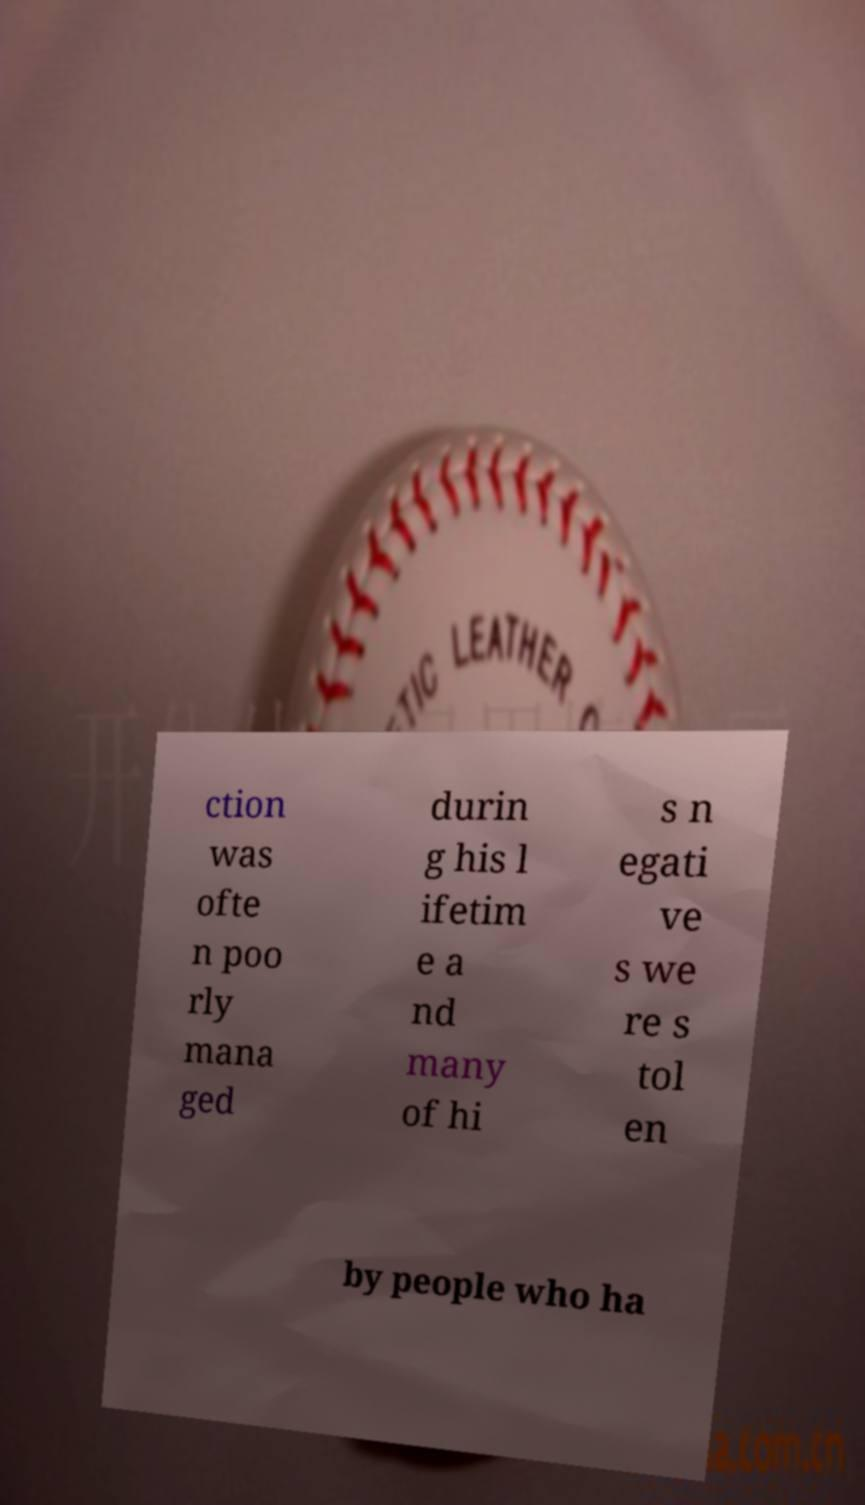I need the written content from this picture converted into text. Can you do that? ction was ofte n poo rly mana ged durin g his l ifetim e a nd many of hi s n egati ve s we re s tol en by people who ha 